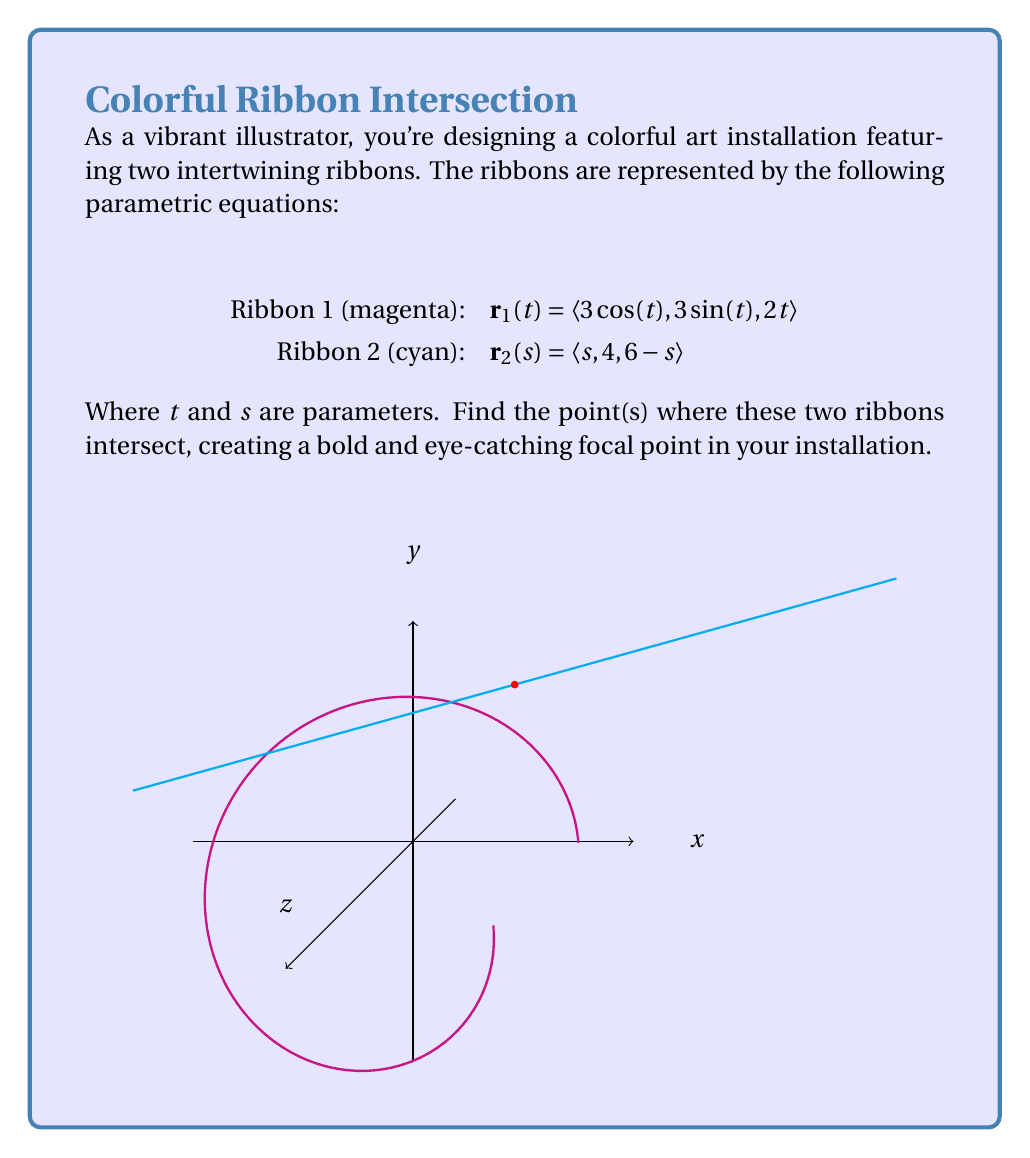Give your solution to this math problem. Let's approach this step-by-step:

1) For the ribbons to intersect, their x, y, and z components must be equal:

   $3\cos(t) = s$
   $3\sin(t) = 4$
   $2t = 6-s$

2) From the second equation:
   $\sin(t) = \frac{4}{3}$

3) This means:
   $\cos(t) = \pm\sqrt{1-\sin^2(t)} = \pm\sqrt{1-(\frac{4}{3})^2} = \pm\frac{\sqrt{5}}{3}$

4) From the first equation:
   $s = 3\cos(t) = \pm\sqrt{5}$

5) We can determine which sign to use by considering the third equation:
   $2t = 6-s$
   $2t = 6 \mp \sqrt{5}$
   $t = 3 \mp \frac{\sqrt{5}}{2}$

6) We need $t$ to be in the first quadrant for $\sin(t)$ to be positive, so:
   $t = 3 - \frac{\sqrt{5}}{2}$
   $s = \sqrt{5}$

7) Now we can find the intersection point:
   $x = 3\cos(t) = \sqrt{5}$
   $y = 3\sin(t) = 4$
   $z = 2t = 6-s = 6-\sqrt{5}$

Therefore, the ribbons intersect at the point $(\sqrt{5}, 4, 6-\sqrt{5})$.
Answer: $(\sqrt{5}, 4, 6-\sqrt{5})$ 